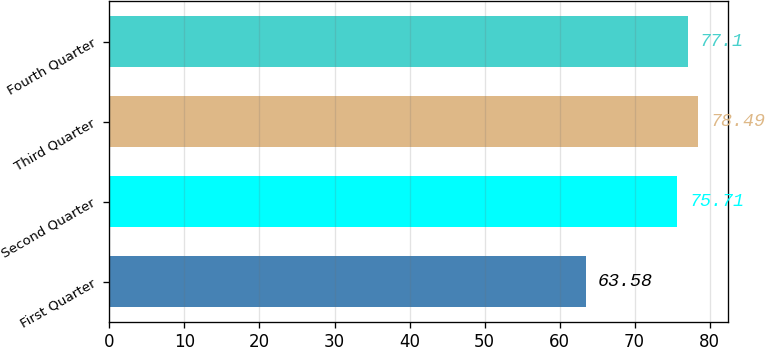<chart> <loc_0><loc_0><loc_500><loc_500><bar_chart><fcel>First Quarter<fcel>Second Quarter<fcel>Third Quarter<fcel>Fourth Quarter<nl><fcel>63.58<fcel>75.71<fcel>78.49<fcel>77.1<nl></chart> 